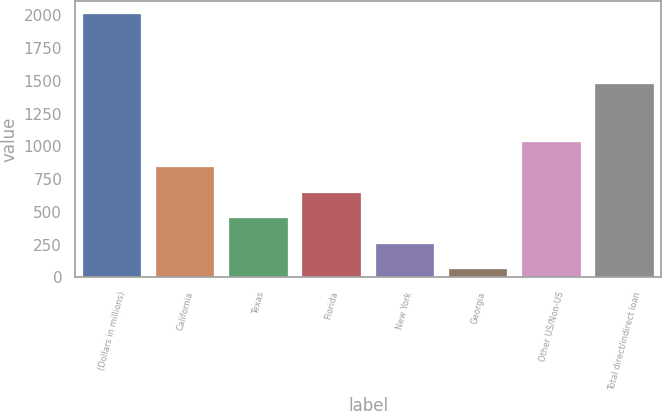<chart> <loc_0><loc_0><loc_500><loc_500><bar_chart><fcel>(Dollars in millions)<fcel>California<fcel>Texas<fcel>Florida<fcel>New York<fcel>Georgia<fcel>Other US/Non-US<fcel>Total direct/indirect loan<nl><fcel>2011<fcel>841<fcel>451<fcel>646<fcel>256<fcel>61<fcel>1036<fcel>1476<nl></chart> 